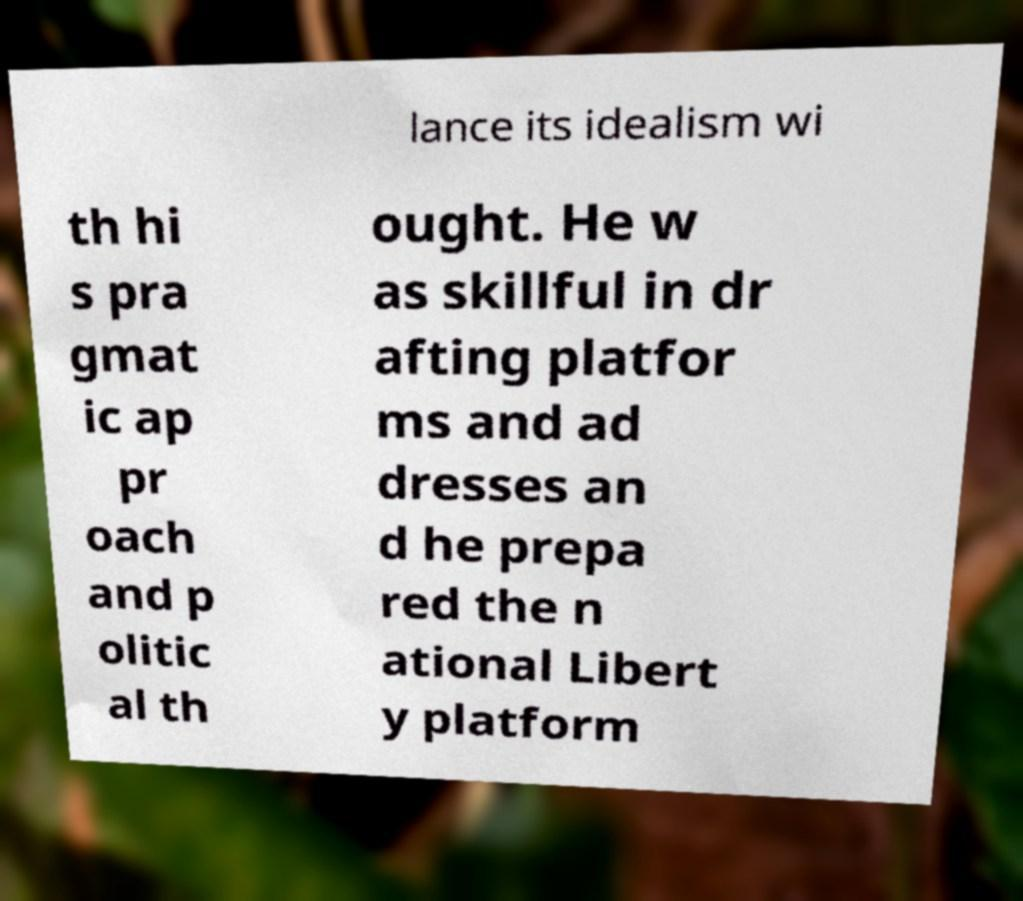Could you assist in decoding the text presented in this image and type it out clearly? lance its idealism wi th hi s pra gmat ic ap pr oach and p olitic al th ought. He w as skillful in dr afting platfor ms and ad dresses an d he prepa red the n ational Libert y platform 